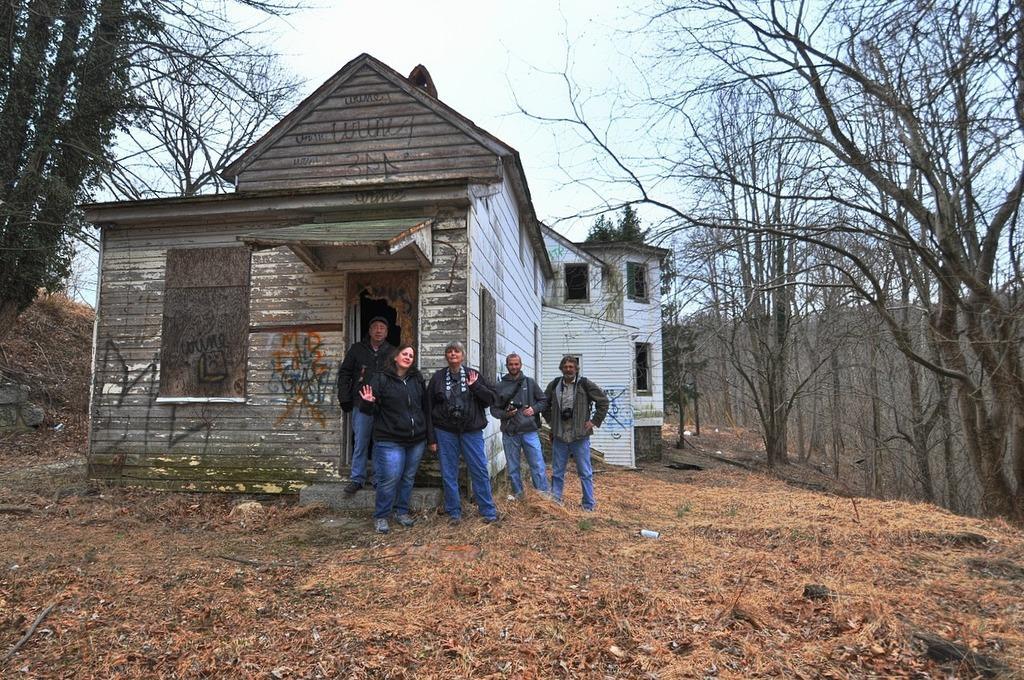How would you summarize this image in a sentence or two? In the middle of the image few people are standing. Behind them there is a house and trees. At the top of the image there are some clouds and sky. 